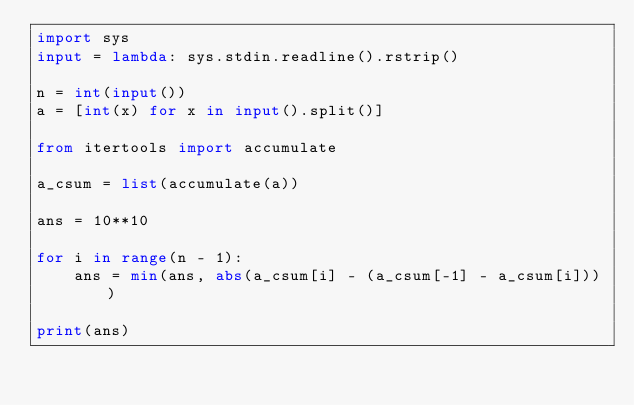Convert code to text. <code><loc_0><loc_0><loc_500><loc_500><_Python_>import sys
input = lambda: sys.stdin.readline().rstrip()

n = int(input())
a = [int(x) for x in input().split()]

from itertools import accumulate

a_csum = list(accumulate(a))

ans = 10**10

for i in range(n - 1):
    ans = min(ans, abs(a_csum[i] - (a_csum[-1] - a_csum[i])))

print(ans)</code> 